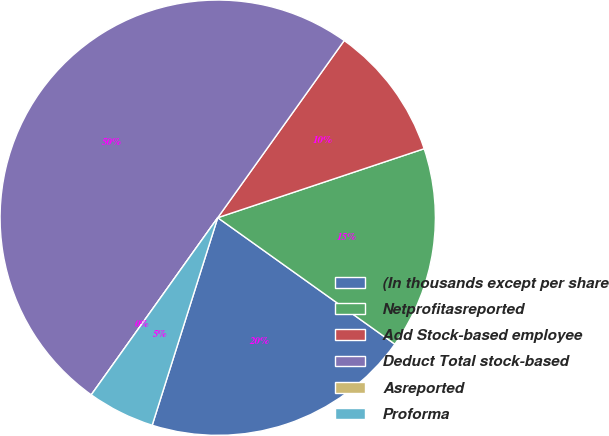Convert chart to OTSL. <chart><loc_0><loc_0><loc_500><loc_500><pie_chart><fcel>(In thousands except per share<fcel>Netprofitasreported<fcel>Add Stock-based employee<fcel>Deduct Total stock-based<fcel>Asreported<fcel>Proforma<nl><fcel>20.0%<fcel>15.0%<fcel>10.0%<fcel>50.0%<fcel>0.0%<fcel>5.0%<nl></chart> 